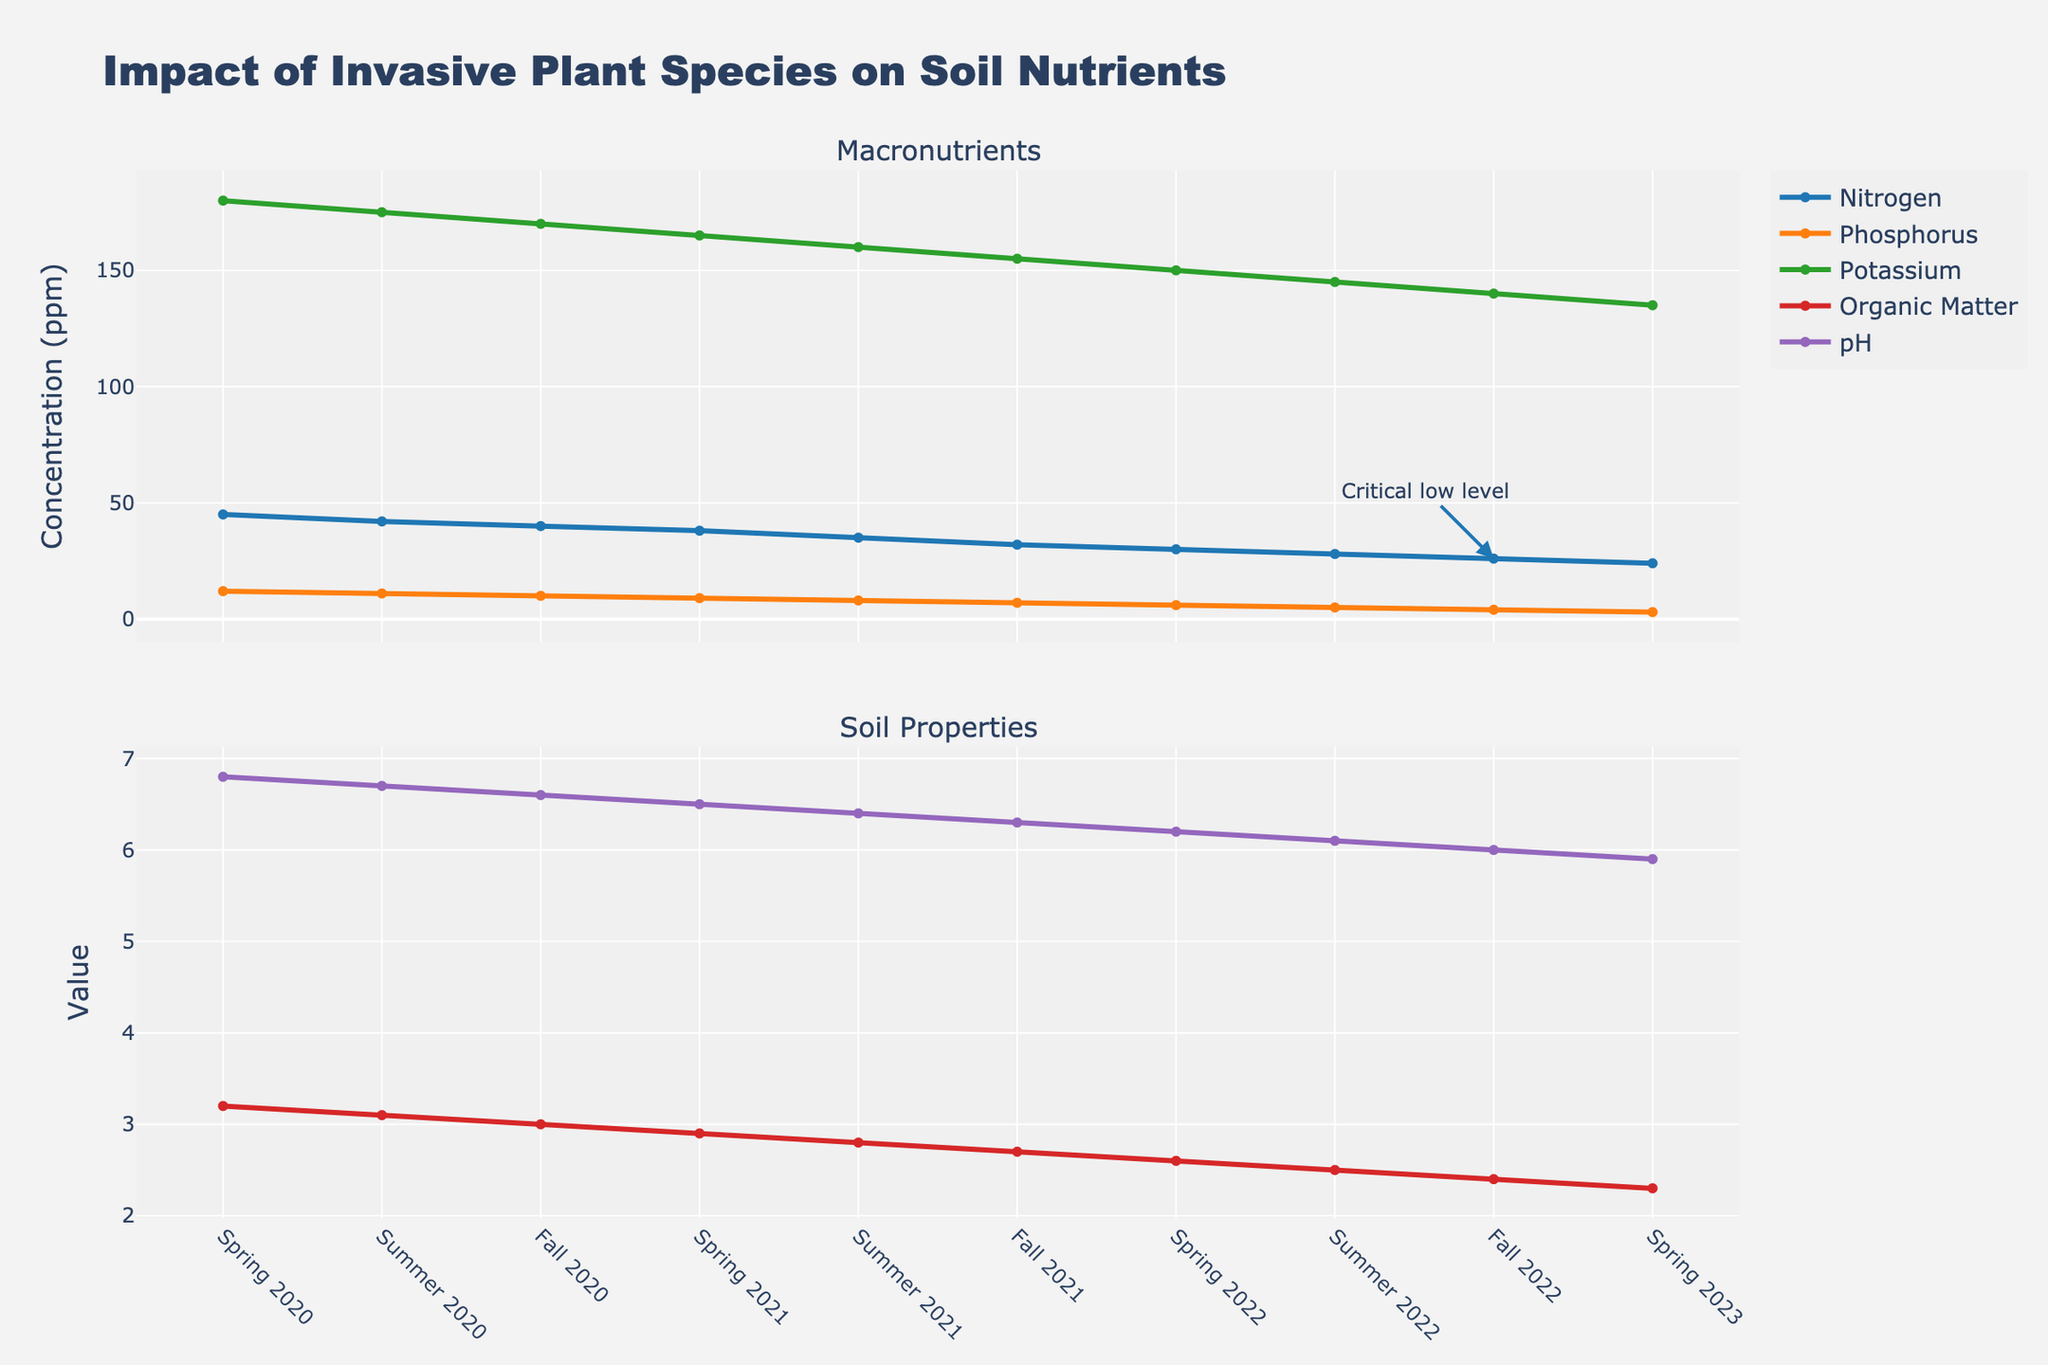What trend is observed in the levels of Nitrogen (ppm) from Spring 2020 to Spring 2023? The chart shows the Nitrogen levels decreasing consistently from 45 ppm in Spring 2020 to 24 ppm in Spring 2023. This downward trend indicates a continuous decline in Nitrogen over time.
Answer: Continuous decline During what season and year did the pH level drop to 6.1? Observing the second subplot (Soil Properties), the pH level reached 6.1 in Summer 2022. This can be identified by tracing where the pH line intersects the 6.1 mark on the y-axis.
Answer: Summer 2022 By how much did the Phosphorus (ppm) decrease from Spring 2020 to Fall 2022? The initial Phosphorus level in Spring 2020 is 12 ppm, and in Fall 2022, it is 4 ppm. Subtracting the two gives 12 ppm - 4 ppm = 8 ppm.
Answer: 8 ppm Which macronutrient experienced the fastest rate of decline over the observed periods? By comparing the slopes of the Nitrogen, Phosphorus, and Potassium lines, the Phosphorus line shows the steepest decline. This indicates Phosphorus had the fastest rate of reduction.
Answer: Phosphorus What is the change in Organic Matter (%) from Spring 2021 to Spring 2023? The Organic Matter level in Spring 2021 is 2.9%, and in Spring 2023 it is 2.3%. Subtracting these values gives 2.9% - 2.3% = 0.6%.
Answer: 0.6% In which season and year was the Potassium (ppm) level closest to 150 ppm? Observing the first subplot, the Potassium level is 150 ppm in Spring 2022. This can be found by locating where the Potassium line intersects the 150 ppm mark on the y-axis.
Answer: Spring 2022 Compare the Organic Matter (%) levels in Summer 2020 and Summer 2021. In Summer 2020, the Organic Matter level is 3.1%, and in Summer 2021, it is 2.8%.
Answer: Lower in Summer 2021 What is the median pH level across all seasons? Arrange all the pH values and find the middle one(s). The pH levels are [5.9, 6.0, 6.1, 6.2, 6.3, 6.4, 6.5, 6.6, 6.7, 6.8], and the median (average of middle two values) is (6.4 + 6.5) / 2 = 6.45.
Answer: 6.45 During which season and year did the Nitrogen (ppm) level reach a "Critical low level" as indicated by an annotation in the plot? The "Critical low level" annotation points to Fall 2022 with a Nitrogen level of 26 ppm.
Answer: Fall 2022 